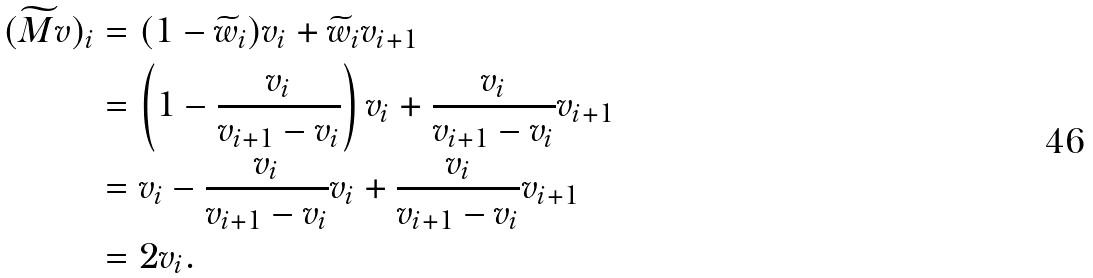<formula> <loc_0><loc_0><loc_500><loc_500>( \widetilde { M } v ) _ { i } & = ( 1 - \widetilde { w } _ { i } ) v _ { i } + \widetilde { w } _ { i } v _ { i + 1 } \\ & = \left ( 1 - \frac { v _ { i } } { v _ { i + 1 } - v _ { i } } \right ) v _ { i } + \frac { v _ { i } } { v _ { i + 1 } - v _ { i } } v _ { i + 1 } \\ & = v _ { i } - \frac { v _ { i } } { v _ { i + 1 } - v _ { i } } v _ { i } + \frac { v _ { i } } { v _ { i + 1 } - v _ { i } } v _ { i + 1 } \\ & = 2 v _ { i } .</formula> 